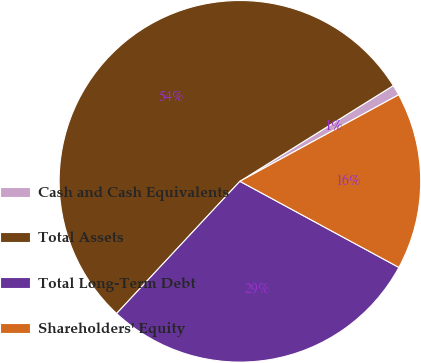<chart> <loc_0><loc_0><loc_500><loc_500><pie_chart><fcel>Cash and Cash Equivalents<fcel>Total Assets<fcel>Total Long-Term Debt<fcel>Shareholders' Equity<nl><fcel>0.94%<fcel>54.17%<fcel>29.04%<fcel>15.84%<nl></chart> 